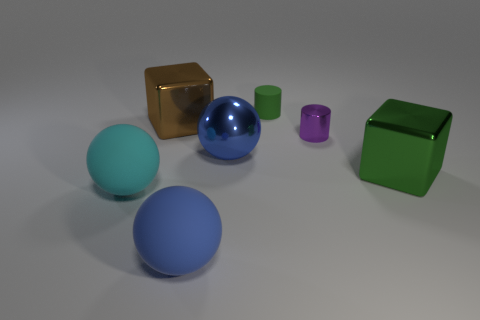Do the thing to the right of the purple thing and the rubber cylinder have the same color?
Your response must be concise. Yes. There is another big thing that is the same shape as the large green metal object; what color is it?
Keep it short and to the point. Brown. What number of large objects are either yellow cylinders or metallic cylinders?
Your answer should be very brief. 0. There is a matte thing left of the brown object; what is its size?
Provide a short and direct response. Large. Is there a rubber sphere of the same color as the metal ball?
Keep it short and to the point. Yes. The matte thing that is the same color as the big metal sphere is what shape?
Offer a terse response. Sphere. There is a green thing behind the big brown cube; how many cylinders are to the right of it?
Offer a terse response. 1. How many large green cubes are the same material as the brown thing?
Keep it short and to the point. 1. Are there any small green matte cylinders behind the metallic sphere?
Offer a terse response. Yes. What is the color of the thing that is the same size as the metallic cylinder?
Give a very brief answer. Green. 